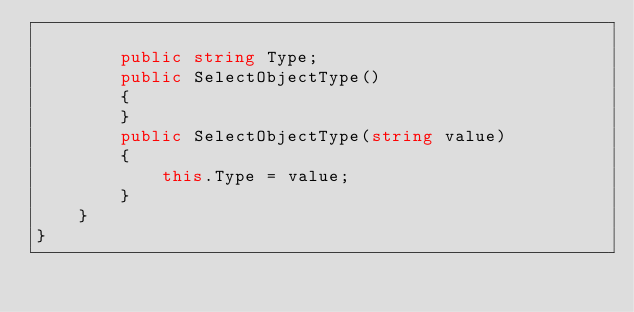<code> <loc_0><loc_0><loc_500><loc_500><_C#_>
        public string Type;
        public SelectObjectType()
        {
        }
        public SelectObjectType(string value)
        {
            this.Type = value;
        }
    }
}
</code> 